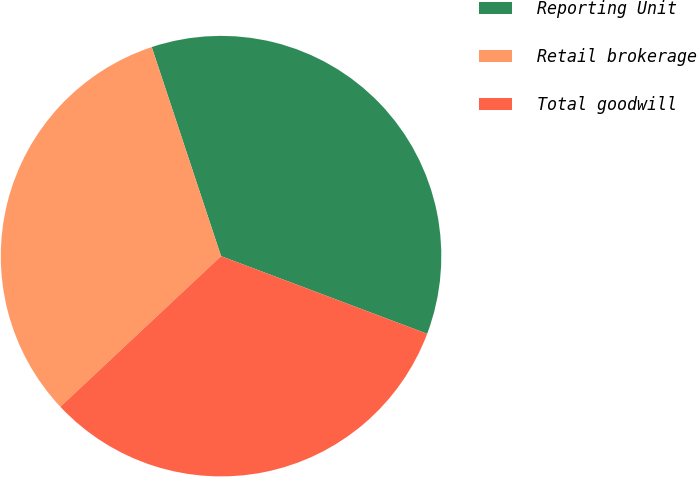<chart> <loc_0><loc_0><loc_500><loc_500><pie_chart><fcel>Reporting Unit<fcel>Retail brokerage<fcel>Total goodwill<nl><fcel>35.83%<fcel>31.89%<fcel>32.28%<nl></chart> 